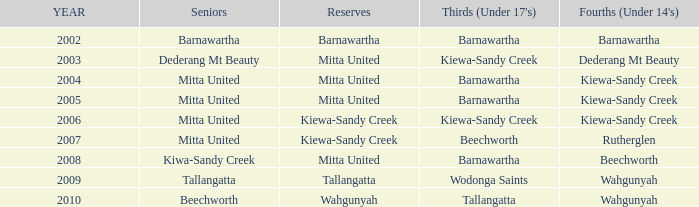Which seniors have a year after 2005, a Reserve of kiewa-sandy creek, and Fourths (Under 14's) of kiewa-sandy creek? Mitta United. 